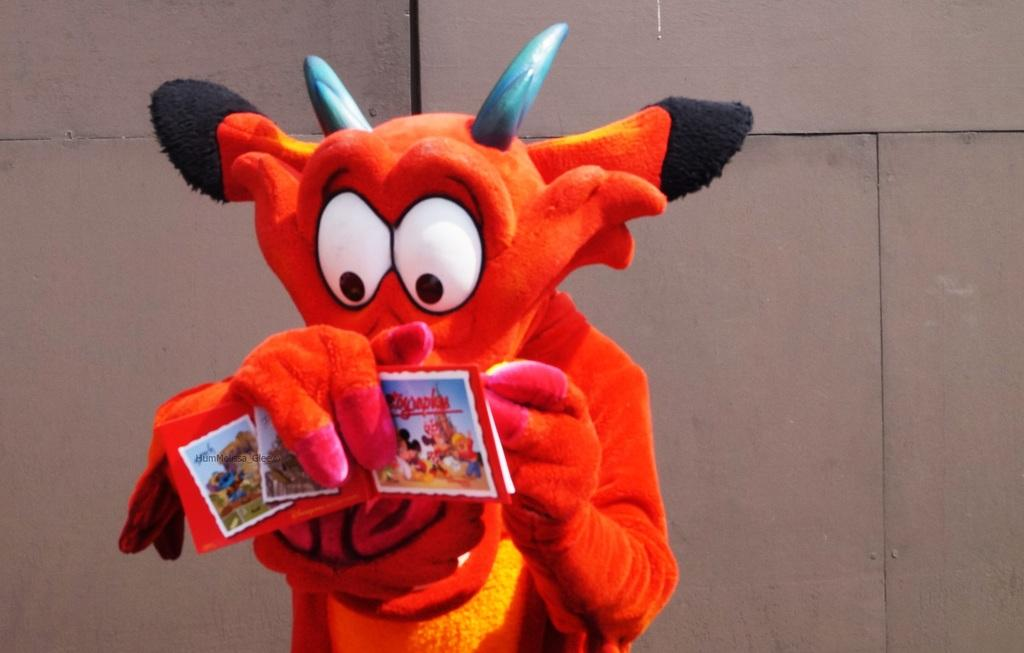What is the person in the image wearing? The person in the image is wearing a costume. What can be seen in the background of the image? There is a wall in the background of the image. How many spiders are crawling on the costume in the image? There are no spiders visible in the image; the person is wearing a costume, but there is no mention of spiders. 